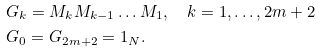<formula> <loc_0><loc_0><loc_500><loc_500>& G _ { k } = M _ { k } M _ { k - 1 } \dots M _ { 1 } , \quad k = 1 , \dots , 2 m + 2 \\ & G _ { 0 } = G _ { 2 m + 2 } = 1 _ { N } .</formula> 